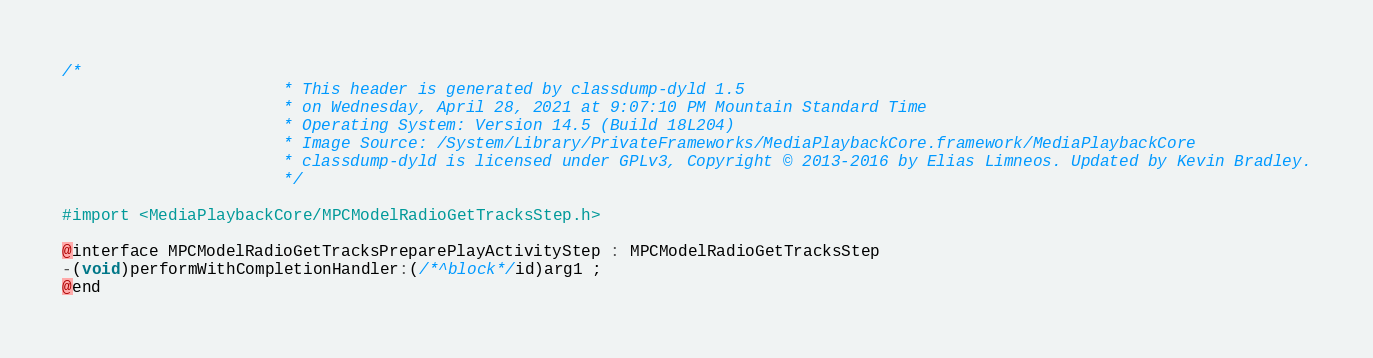Convert code to text. <code><loc_0><loc_0><loc_500><loc_500><_C_>/*
                       * This header is generated by classdump-dyld 1.5
                       * on Wednesday, April 28, 2021 at 9:07:10 PM Mountain Standard Time
                       * Operating System: Version 14.5 (Build 18L204)
                       * Image Source: /System/Library/PrivateFrameworks/MediaPlaybackCore.framework/MediaPlaybackCore
                       * classdump-dyld is licensed under GPLv3, Copyright © 2013-2016 by Elias Limneos. Updated by Kevin Bradley.
                       */

#import <MediaPlaybackCore/MPCModelRadioGetTracksStep.h>

@interface MPCModelRadioGetTracksPreparePlayActivityStep : MPCModelRadioGetTracksStep
-(void)performWithCompletionHandler:(/*^block*/id)arg1 ;
@end

</code> 